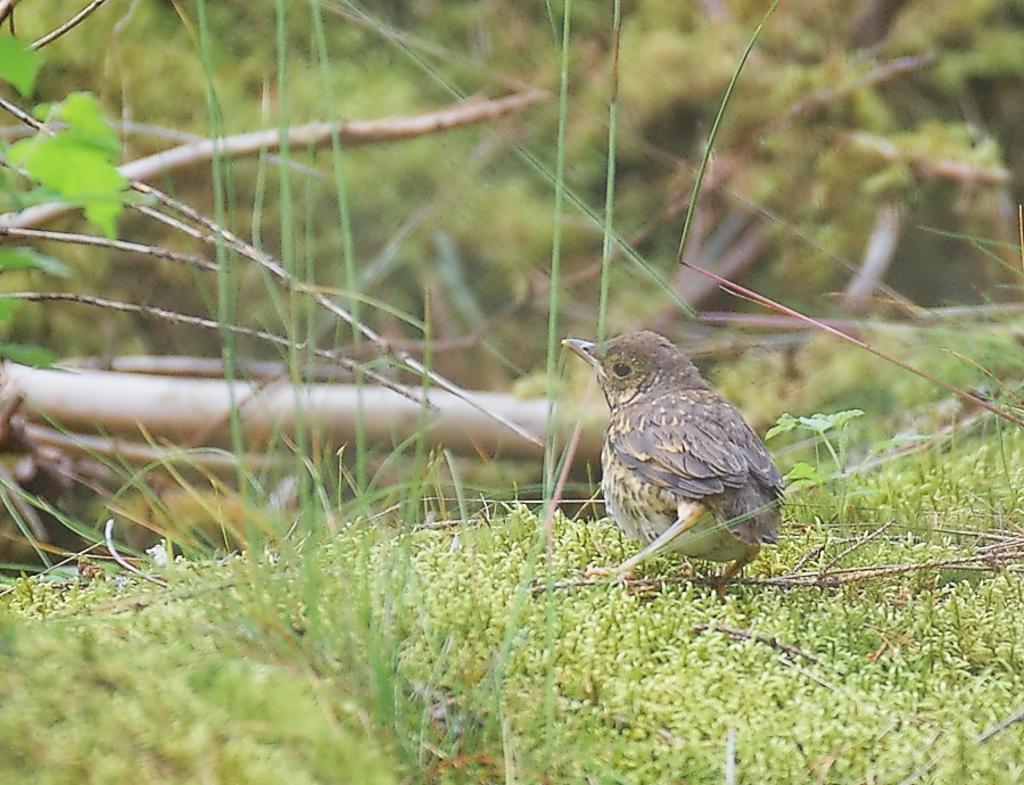In one or two sentences, can you explain what this image depicts? In the picture there is a small bird standing on the grass and the background of the bird is blue. 